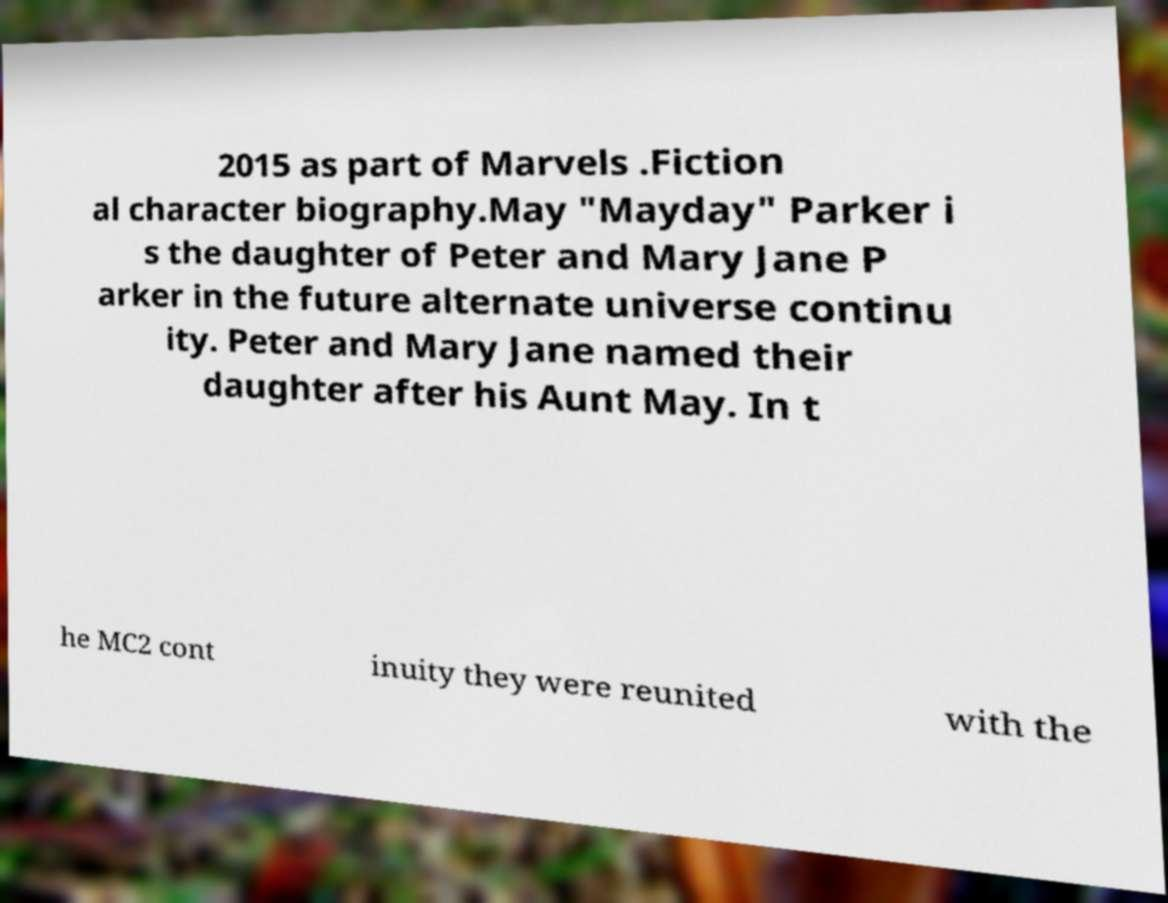For documentation purposes, I need the text within this image transcribed. Could you provide that? 2015 as part of Marvels .Fiction al character biography.May "Mayday" Parker i s the daughter of Peter and Mary Jane P arker in the future alternate universe continu ity. Peter and Mary Jane named their daughter after his Aunt May. In t he MC2 cont inuity they were reunited with the 